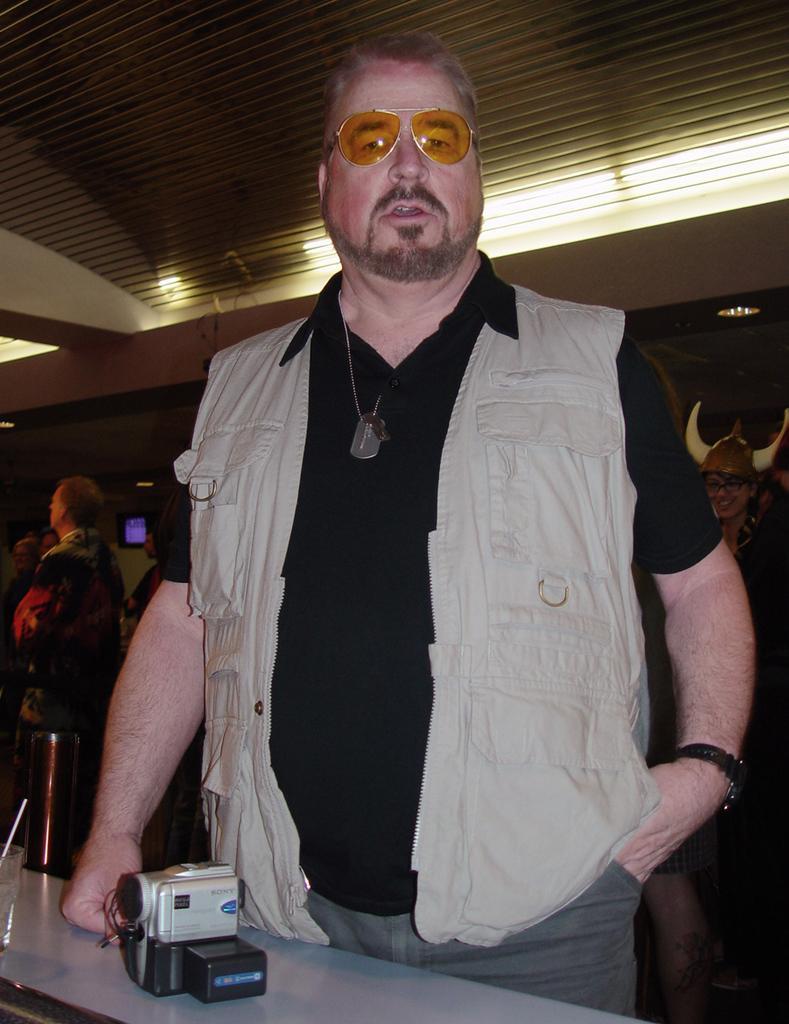Please provide a concise description of this image. In this picture we can see a man, he wore spectacles, in front of him we can find a camera on the table, in the background we can find few more people, and lights. 